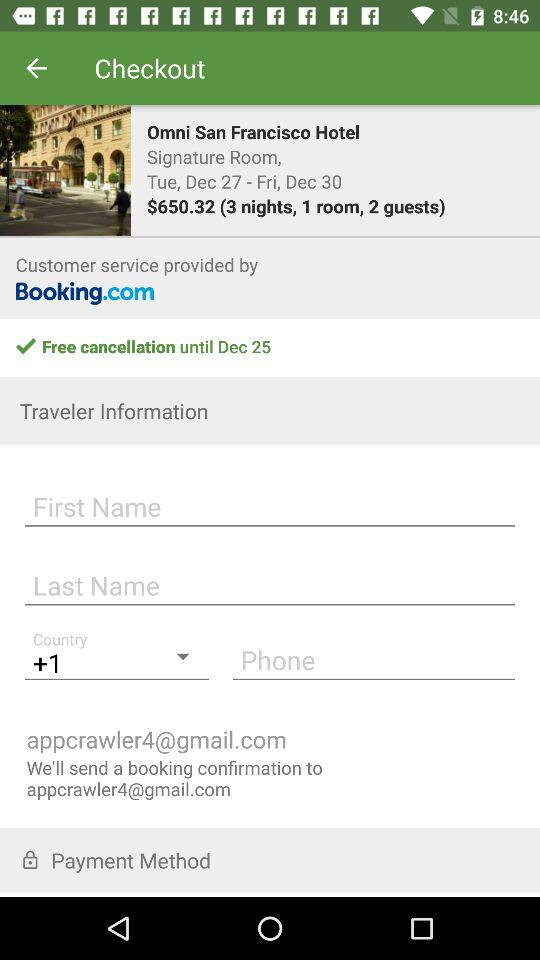What is the email address? The email address is appcrawler4@gmail.com. 